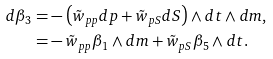Convert formula to latex. <formula><loc_0><loc_0><loc_500><loc_500>d \beta _ { 3 } = & - \left ( \tilde { w } _ { p p } d p + \tilde { w } _ { p S } d S \right ) \wedge d t \wedge d m , \\ = & - \tilde { w } _ { p p } \beta _ { 1 } \wedge d m + \tilde { w } _ { p S } \beta _ { 5 } \wedge d t .</formula> 